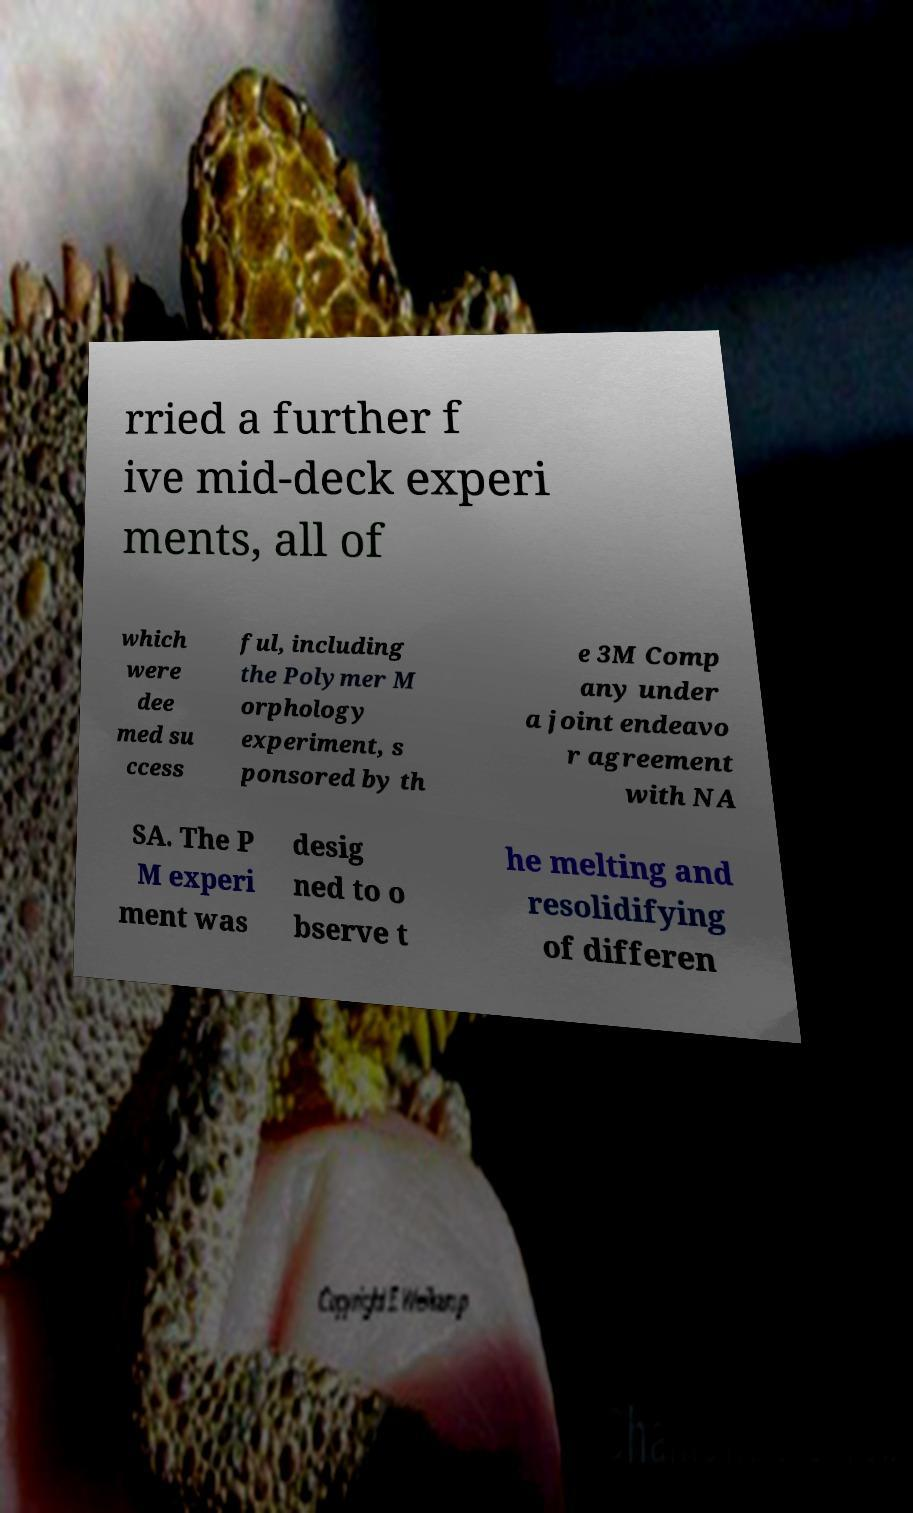Can you accurately transcribe the text from the provided image for me? rried a further f ive mid-deck experi ments, all of which were dee med su ccess ful, including the Polymer M orphology experiment, s ponsored by th e 3M Comp any under a joint endeavo r agreement with NA SA. The P M experi ment was desig ned to o bserve t he melting and resolidifying of differen 